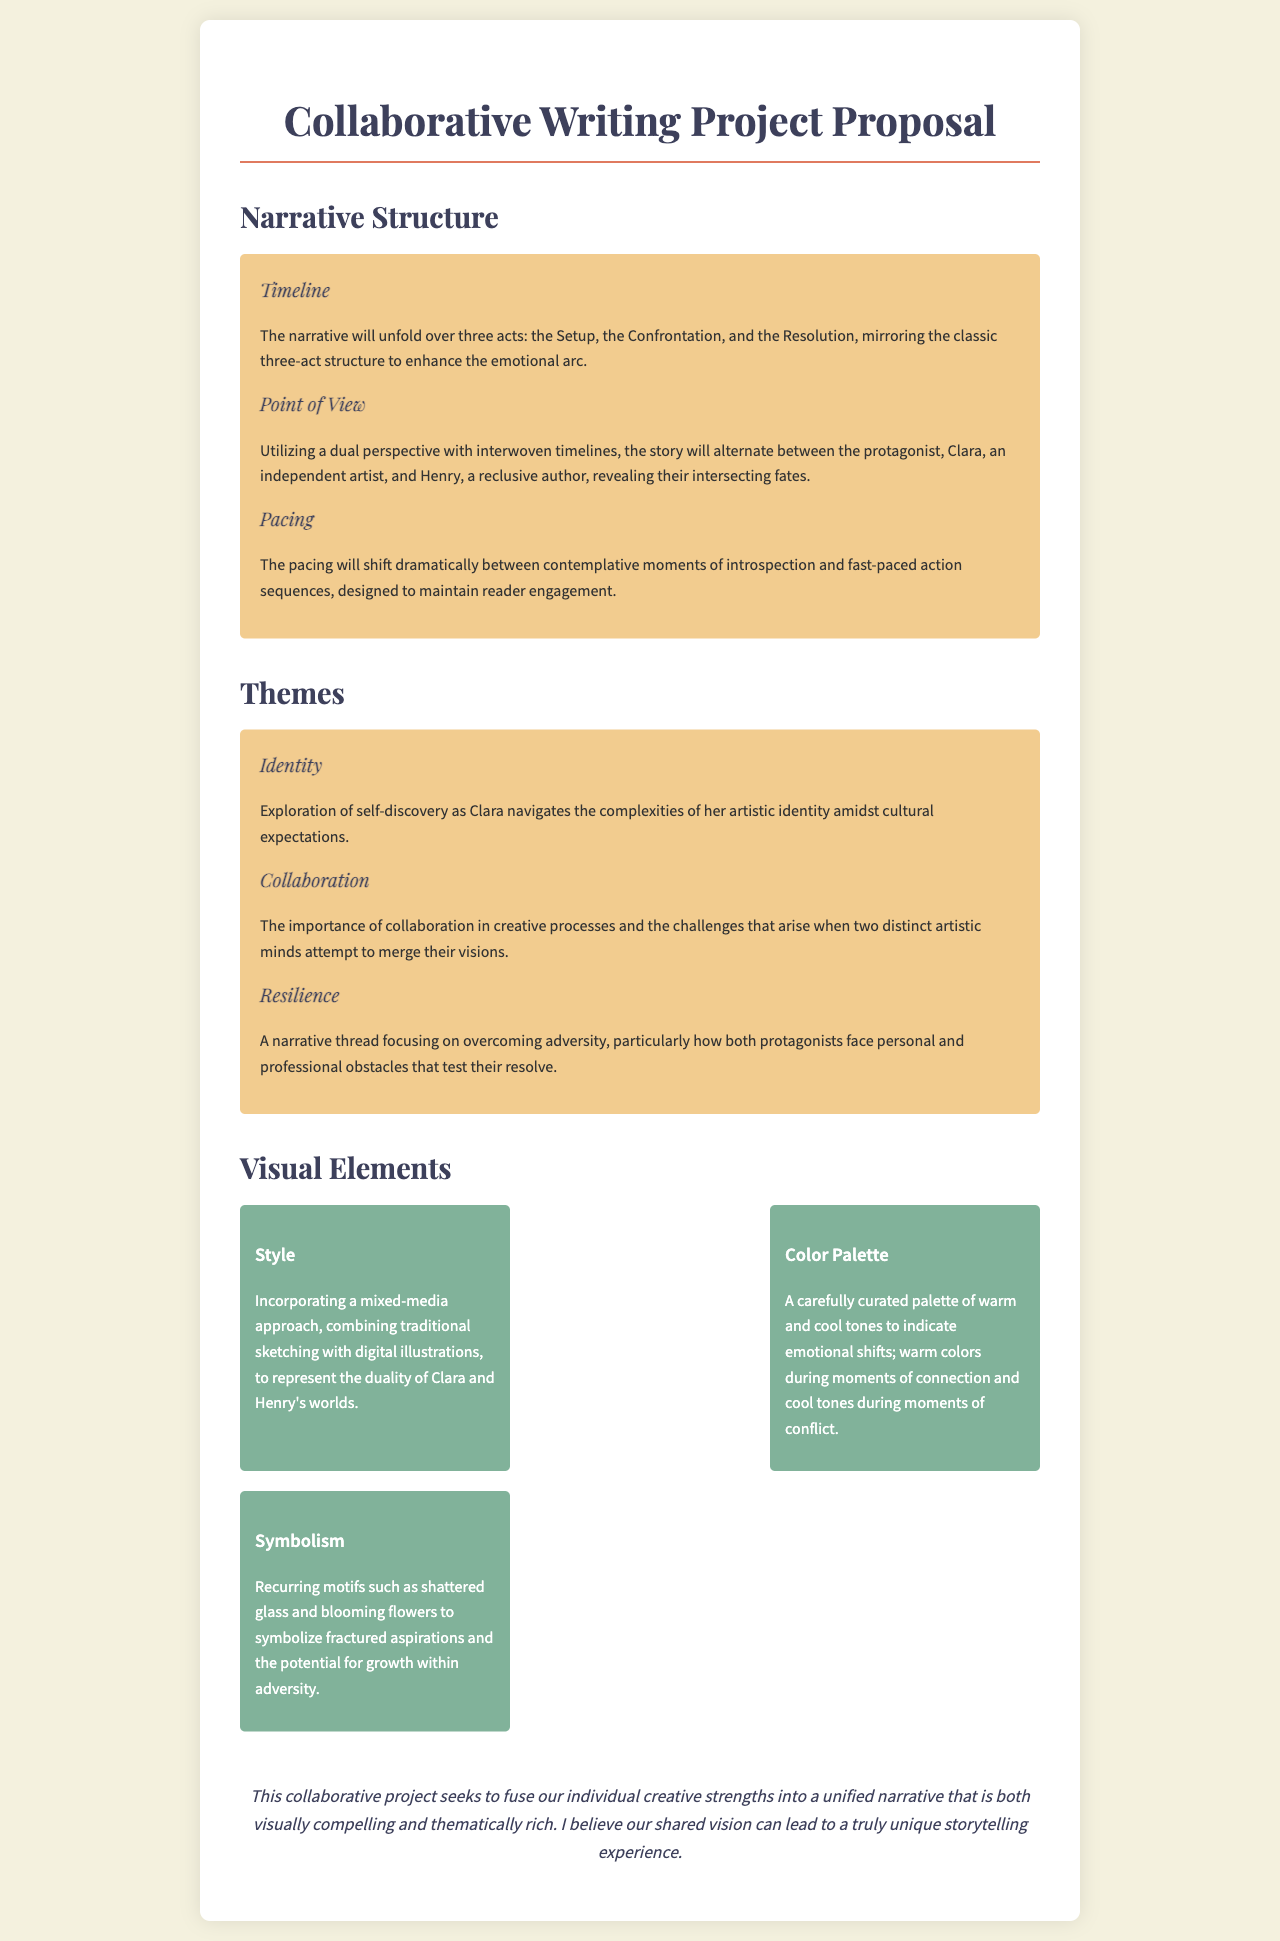what is the title of the proposal? The title of the proposal is presented at the top of the document.
Answer: Collaborative Writing Project Proposal how many acts are in the narrative structure? The number of acts is explicitly mentioned in the narrative structure section.
Answer: three acts who are the two main characters in the narrative? The names of the protagonists are detailed in the dual perspective section of the document.
Answer: Clara and Henry what theme explores overcoming adversity? The theme focusing on overcoming adversity is detailed under the themes section.
Answer: Resilience what color palette indicates emotional shifts? The document specifies a curated palette of colors related to emotional shifts in the visual elements section.
Answer: warm and cool tones what visual style is used to represent Clara and Henry's worlds? The visual style is described in the visual elements section, indicating the type of artistic approach.
Answer: mixed-media approach what recurring motif symbolizes fractured aspirations? The document elaborates on the symbolism used within the narrative.
Answer: shattered glass what is the overall goal of the collaborative project? The aim of the collaboration is summarised in the conclusion of the document.
Answer: fuse individual creative strengths 